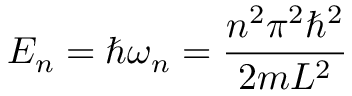Convert formula to latex. <formula><loc_0><loc_0><loc_500><loc_500>E _ { n } = \hbar { \omega } _ { n } = { \frac { n ^ { 2 } \pi ^ { 2 } \hbar { ^ } { 2 } } { 2 m L ^ { 2 } } }</formula> 